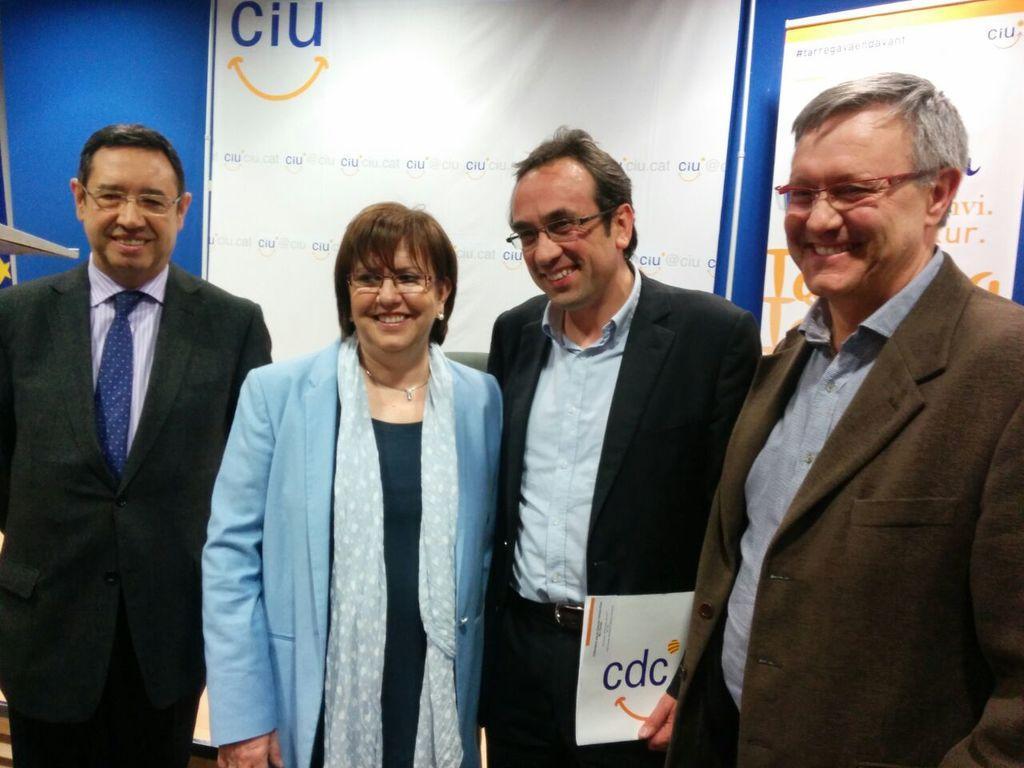Can you describe this image briefly? In this picture we can see three men and a women standing in the front, smiling and giving a pose into the camera. Behind we can see white color banners on the blue wall. 